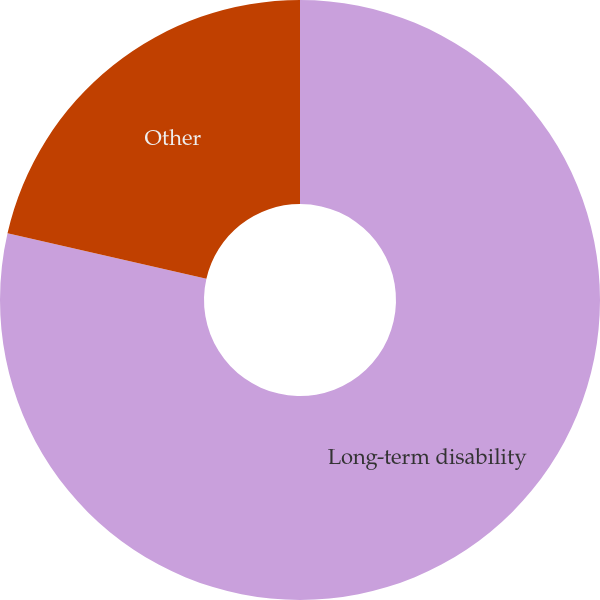Convert chart. <chart><loc_0><loc_0><loc_500><loc_500><pie_chart><fcel>Long-term disability<fcel>Other<nl><fcel>78.57%<fcel>21.43%<nl></chart> 